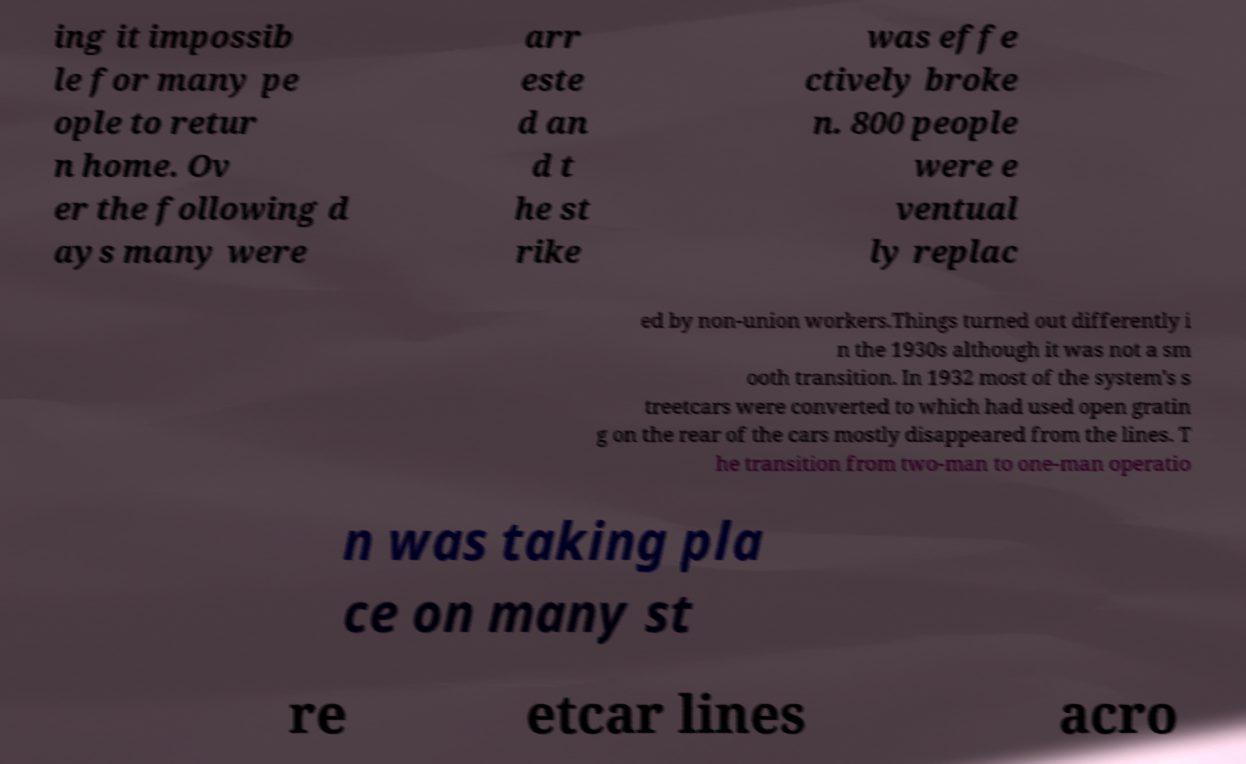Can you accurately transcribe the text from the provided image for me? ing it impossib le for many pe ople to retur n home. Ov er the following d ays many were arr este d an d t he st rike was effe ctively broke n. 800 people were e ventual ly replac ed by non-union workers.Things turned out differently i n the 1930s although it was not a sm ooth transition. In 1932 most of the system's s treetcars were converted to which had used open gratin g on the rear of the cars mostly disappeared from the lines. T he transition from two-man to one-man operatio n was taking pla ce on many st re etcar lines acro 